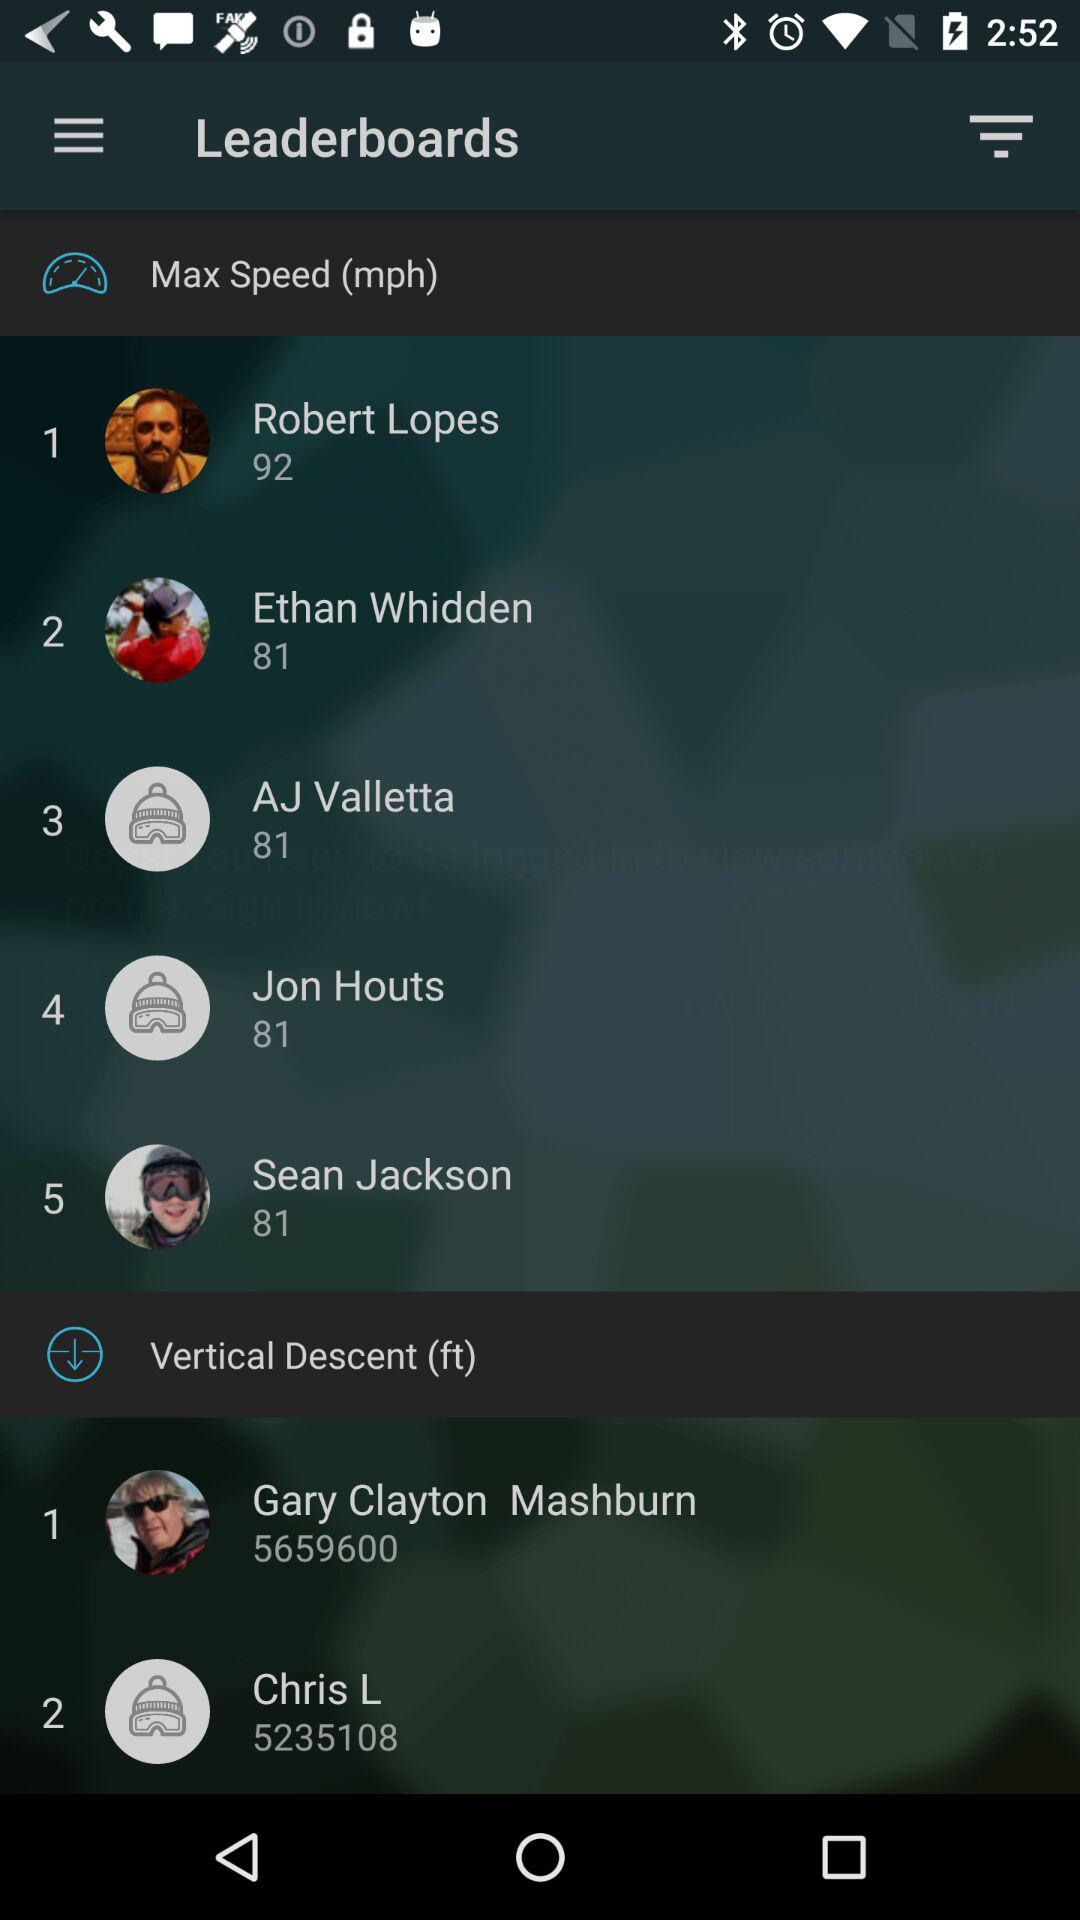Who ranked #1 last week?
When the provided information is insufficient, respond with <no answer>. <no answer> 